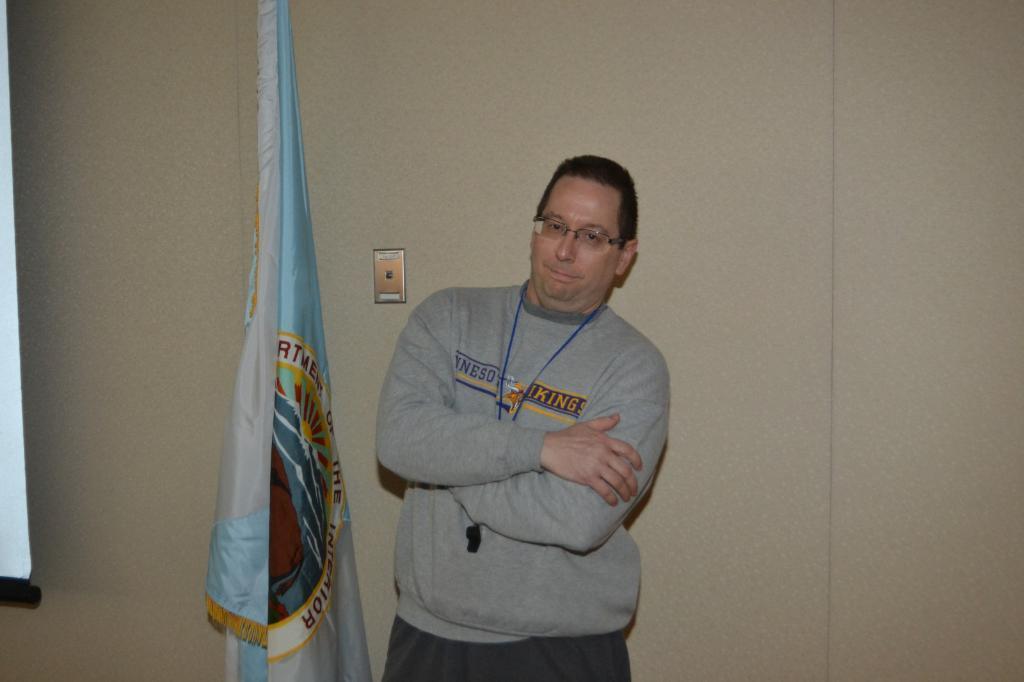How would you summarize this image in a sentence or two? In this picture we can see a man wearing a whistle around his neck. Near to him there is a flag. On the background we can see a wall with cream colour paint. 